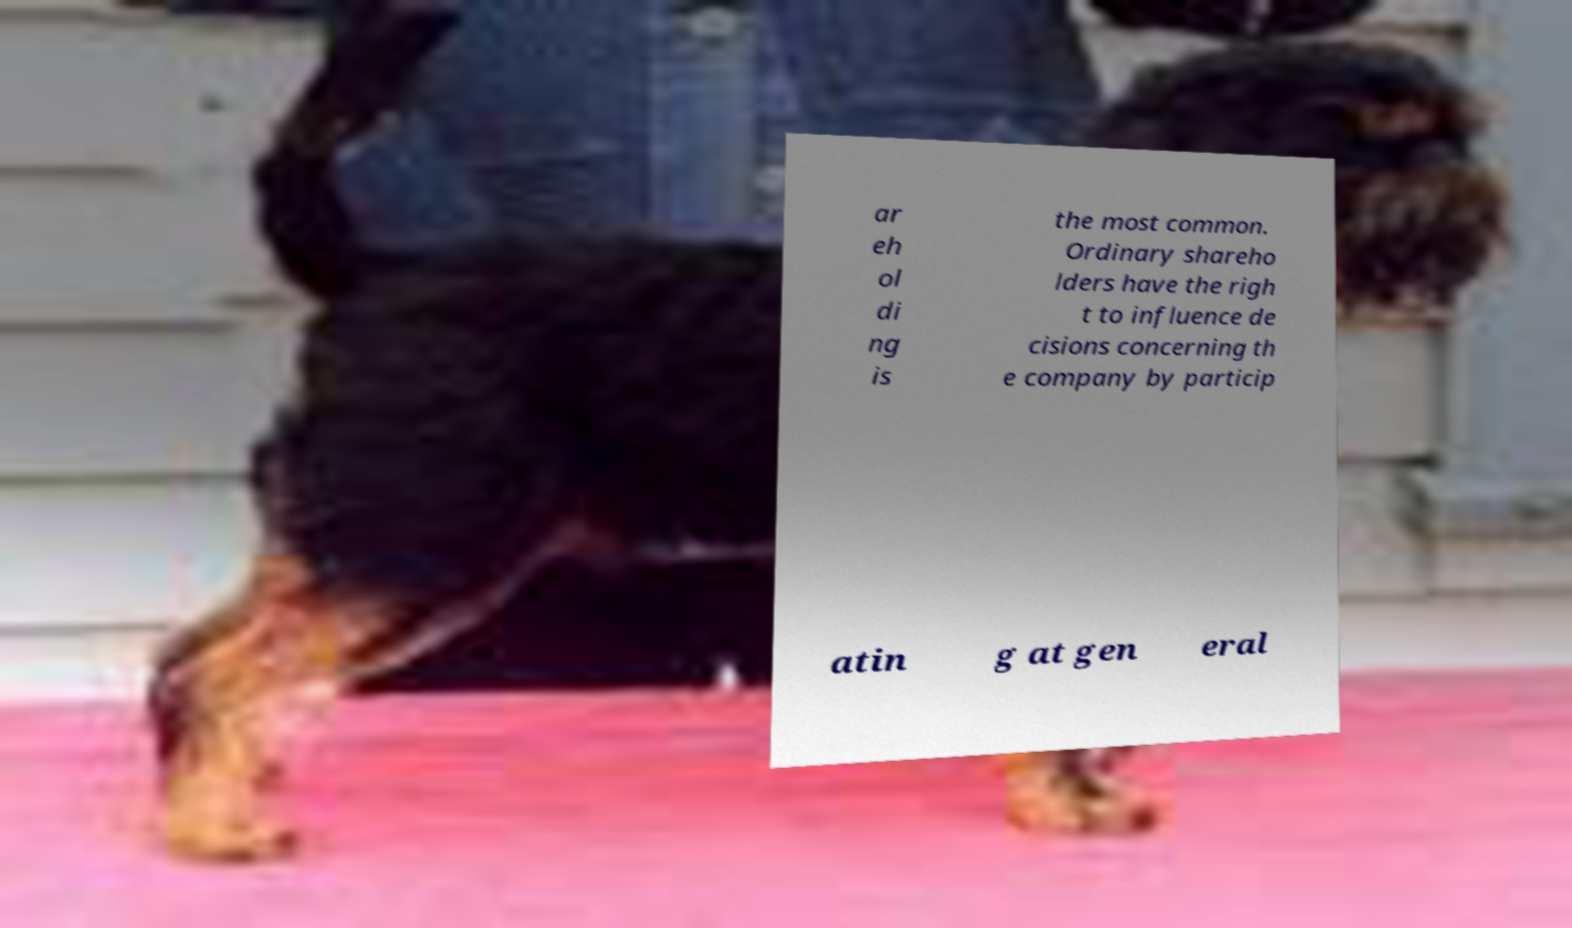Could you extract and type out the text from this image? ar eh ol di ng is the most common. Ordinary shareho lders have the righ t to influence de cisions concerning th e company by particip atin g at gen eral 